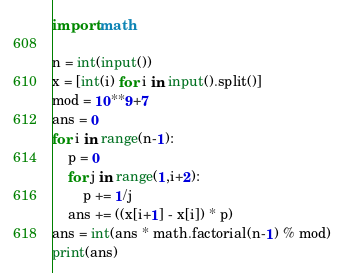<code> <loc_0><loc_0><loc_500><loc_500><_Python_>import math

n = int(input())
x = [int(i) for i in input().split()]
mod = 10**9+7
ans = 0
for i in range(n-1):
    p = 0
    for j in range(1,i+2):
        p += 1/j
    ans += ((x[i+1] - x[i]) * p)
ans = int(ans * math.factorial(n-1) % mod)
print(ans)</code> 